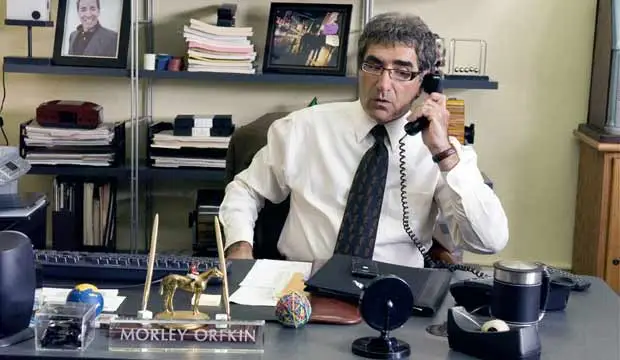What is this photo about? The photo captures a scene in an office where a man, possibly an actor portraying the character Morley Orkin, is seated at a desk while engaged in a phone conversation. He is dressed in a white dress shirt and a striped tie, which adds to the professional ambiance of the setting. The desk is cluttered with various items, including a gold camel statue, a black desk lamp, a blue coffee mug, and other office supplies. Behind him, there is a photo of his character on the wall and a nameplate on his desk indicating 'Morley Orkin', suggesting his significance or authority in this setting. 